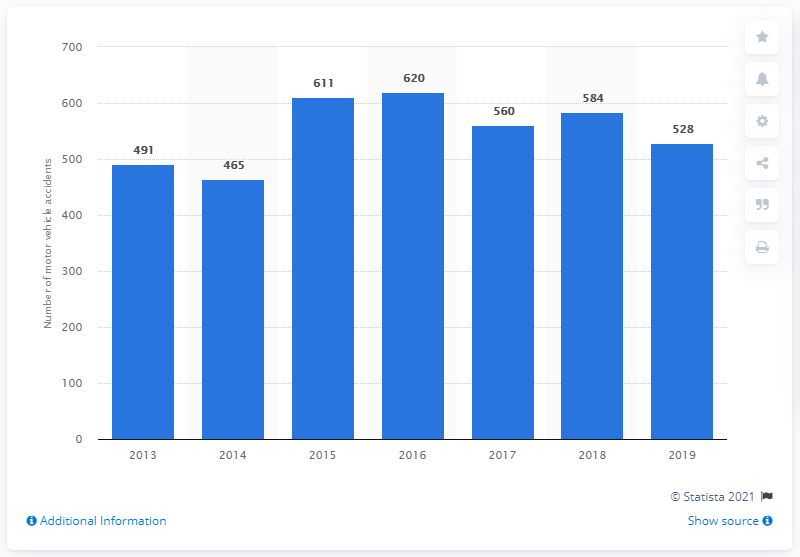Give some essential details in this illustration. In 2019, a total of 528 motor vehicle accidents occurred in Yosemite. The number of motor vehicle accidents in Yosemite during the previous year was 584. 